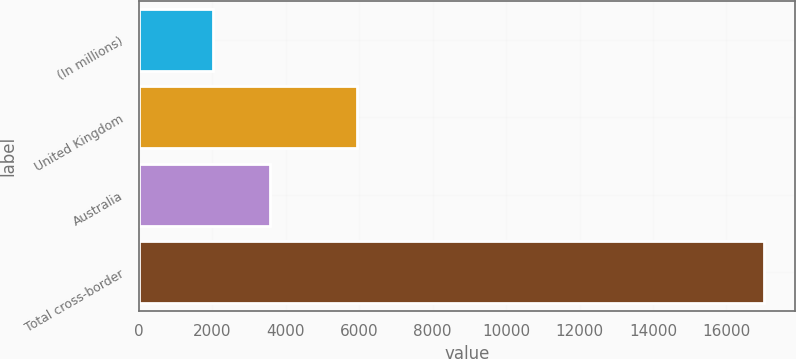Convert chart. <chart><loc_0><loc_0><loc_500><loc_500><bar_chart><fcel>(In millions)<fcel>United Kingdom<fcel>Australia<fcel>Total cross-border<nl><fcel>2007<fcel>5951<fcel>3567<fcel>17027<nl></chart> 